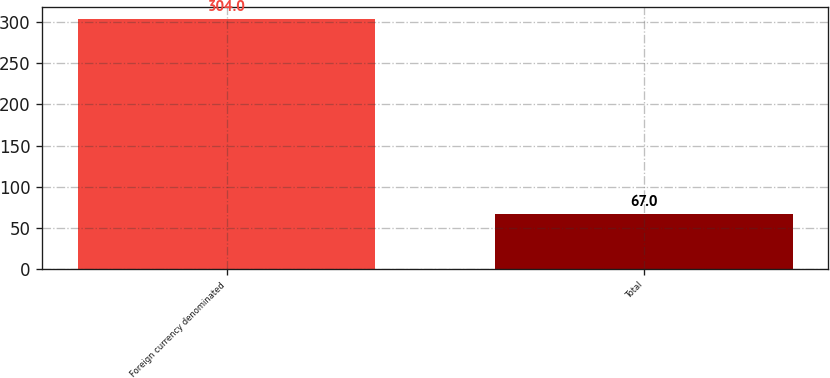Convert chart to OTSL. <chart><loc_0><loc_0><loc_500><loc_500><bar_chart><fcel>Foreign currency denominated<fcel>Total<nl><fcel>304<fcel>67<nl></chart> 